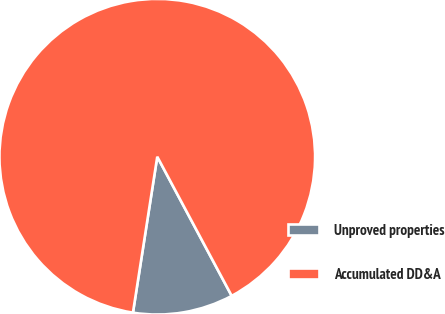Convert chart to OTSL. <chart><loc_0><loc_0><loc_500><loc_500><pie_chart><fcel>Unproved properties<fcel>Accumulated DD&A<nl><fcel>10.28%<fcel>89.72%<nl></chart> 